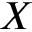<formula> <loc_0><loc_0><loc_500><loc_500>X</formula> 